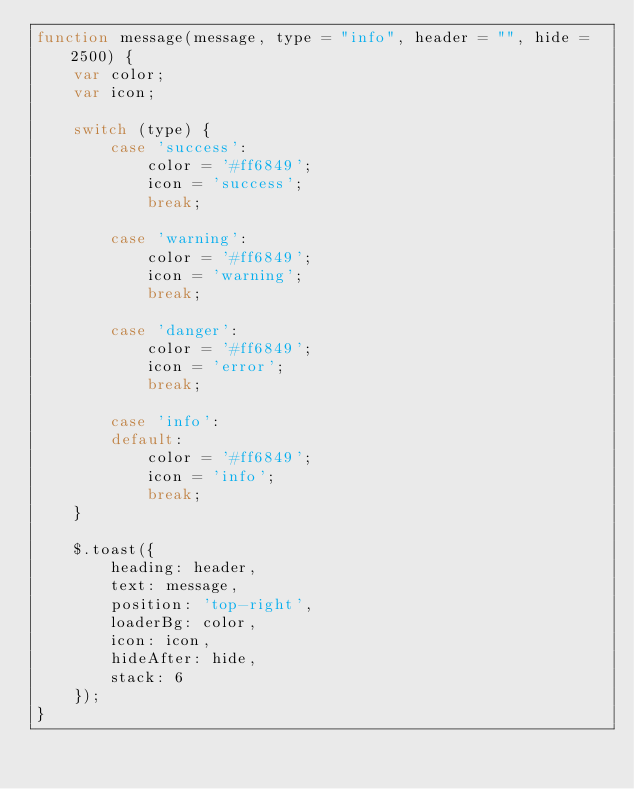Convert code to text. <code><loc_0><loc_0><loc_500><loc_500><_JavaScript_>function message(message, type = "info", header = "", hide = 2500) {
    var color;
    var icon;

    switch (type) {
        case 'success':
            color = '#ff6849';
            icon = 'success';
            break;

        case 'warning':
            color = '#ff6849';
            icon = 'warning';
            break;

        case 'danger':
            color = '#ff6849';
            icon = 'error';
            break;

        case 'info':
        default:
            color = '#ff6849';
            icon = 'info';
            break;
    }
    
    $.toast({
        heading: header,
        text: message,
        position: 'top-right',
        loaderBg: color,
        icon: icon,
        hideAfter: hide,
        stack: 6
    });
}</code> 